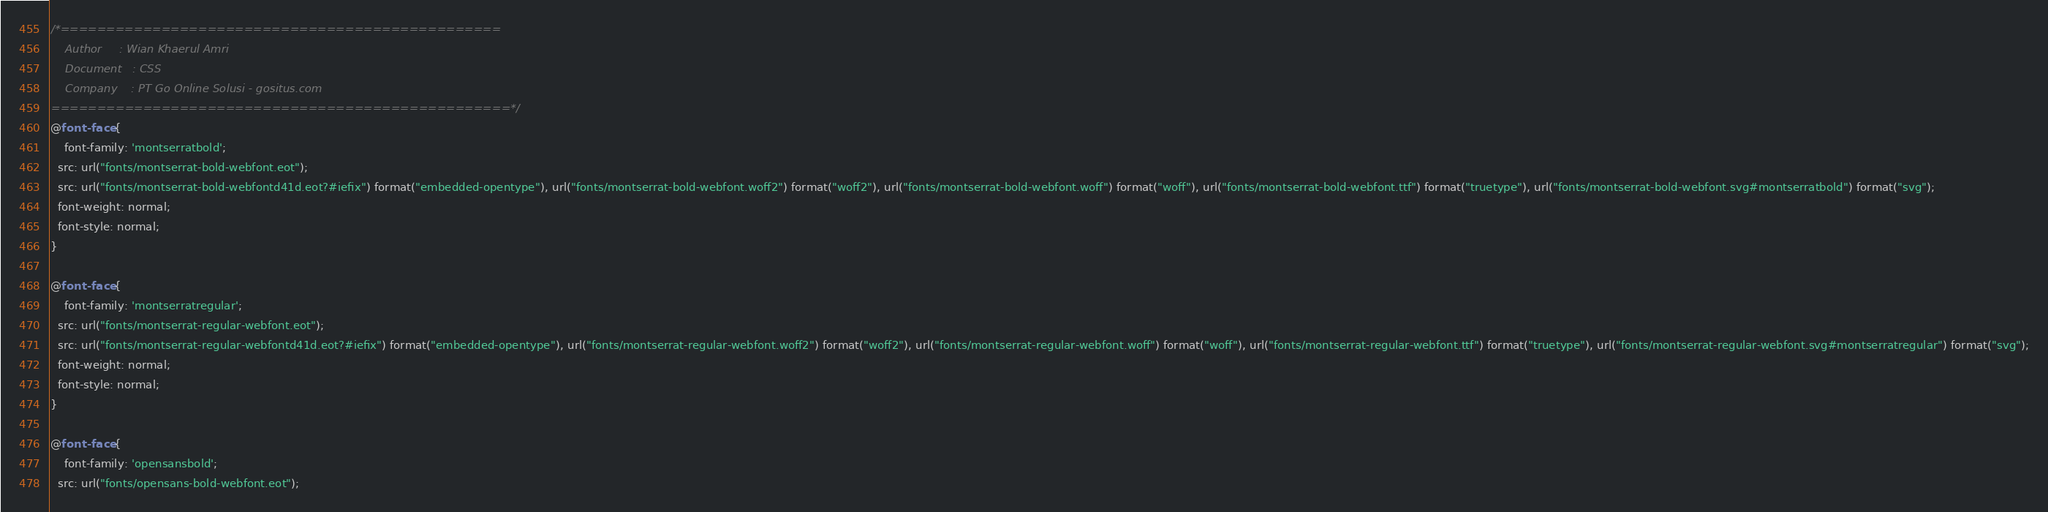<code> <loc_0><loc_0><loc_500><loc_500><_CSS_>/*================================================	
    Author     : Wian Khaerul Amri
    Document   : CSS
    Company    : PT Go Online Solusi - gositus.com
==================================================*/
@font-face {
    font-family: 'montserratbold';
  src: url("fonts/montserrat-bold-webfont.eot");
  src: url("fonts/montserrat-bold-webfontd41d.eot?#iefix") format("embedded-opentype"), url("fonts/montserrat-bold-webfont.woff2") format("woff2"), url("fonts/montserrat-bold-webfont.woff") format("woff"), url("fonts/montserrat-bold-webfont.ttf") format("truetype"), url("fonts/montserrat-bold-webfont.svg#montserratbold") format("svg");
  font-weight: normal;
  font-style: normal;
}

@font-face {
    font-family: 'montserratregular';
  src: url("fonts/montserrat-regular-webfont.eot");
  src: url("fonts/montserrat-regular-webfontd41d.eot?#iefix") format("embedded-opentype"), url("fonts/montserrat-regular-webfont.woff2") format("woff2"), url("fonts/montserrat-regular-webfont.woff") format("woff"), url("fonts/montserrat-regular-webfont.ttf") format("truetype"), url("fonts/montserrat-regular-webfont.svg#montserratregular") format("svg");
  font-weight: normal;
  font-style: normal;
}

@font-face {
    font-family: 'opensansbold';
  src: url("fonts/opensans-bold-webfont.eot");</code> 